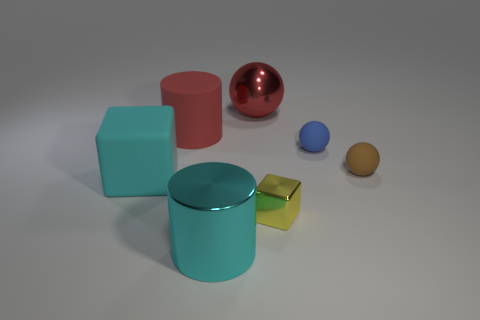Subtract all purple cubes. Subtract all purple spheres. How many cubes are left? 2 Add 1 green rubber cubes. How many objects exist? 8 Subtract all cylinders. How many objects are left? 5 Subtract 0 gray cylinders. How many objects are left? 7 Subtract all green rubber blocks. Subtract all tiny yellow objects. How many objects are left? 6 Add 2 small brown matte spheres. How many small brown matte spheres are left? 3 Add 1 big cyan metallic cubes. How many big cyan metallic cubes exist? 1 